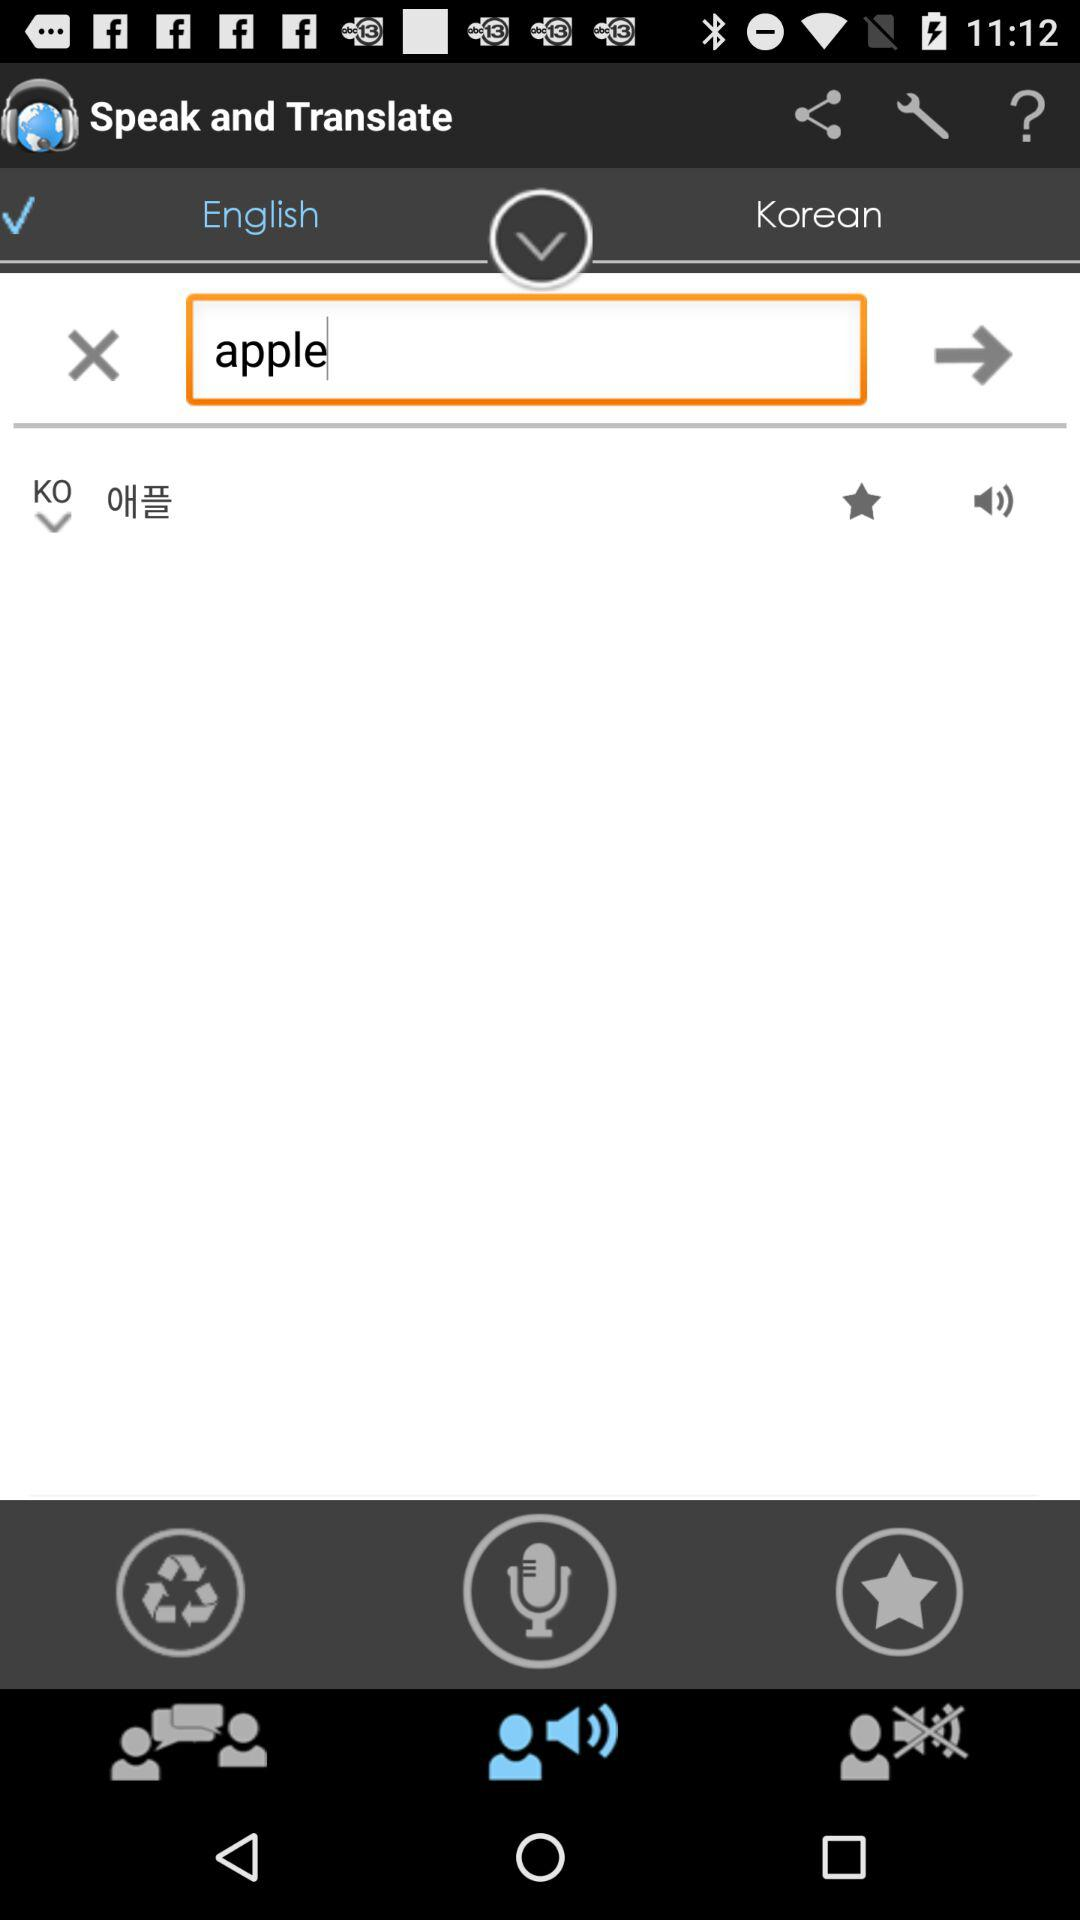Which language is to be translated? The language which is to be translated is English. 